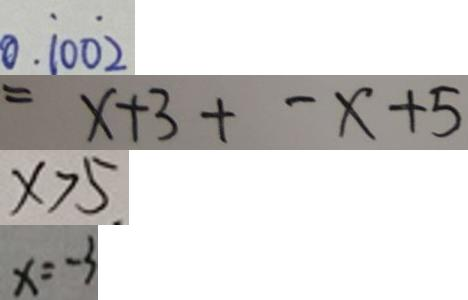Convert formula to latex. <formula><loc_0><loc_0><loc_500><loc_500>0 . \dot { 1 } 0 0 \dot { 2 } 
 = x + 3 + - x + 5 
 x > 5 
 x = - 3</formula> 